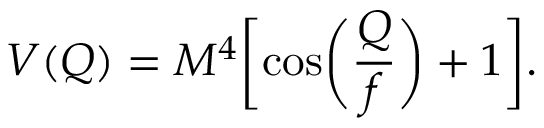Convert formula to latex. <formula><loc_0><loc_0><loc_500><loc_500>V ( Q ) = M ^ { 4 } \left [ \cos \left ( \frac { Q } { f } \right ) + 1 \right ] .</formula> 